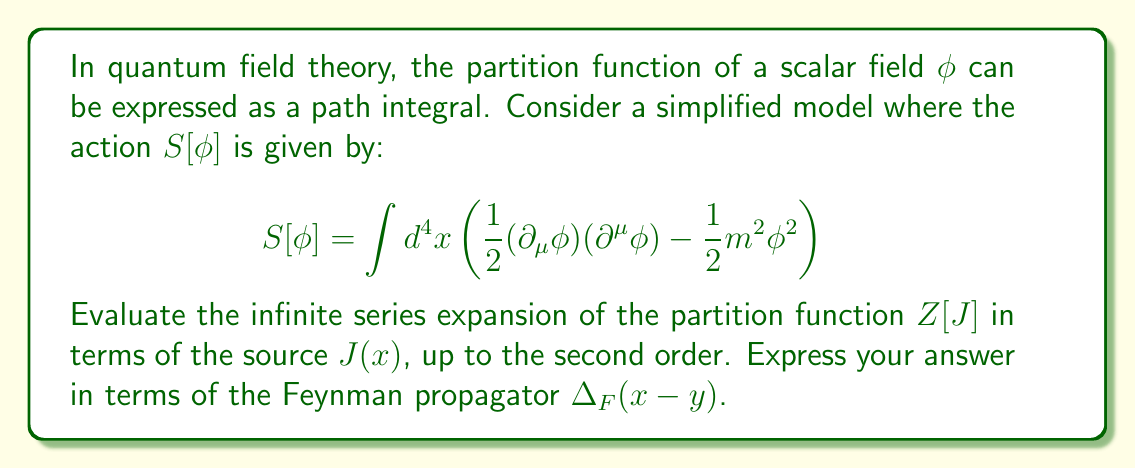Can you answer this question? Let's approach this step-by-step:

1) The partition function $Z[J]$ is given by:

   $$Z[J] = \int \mathcal{D}\phi \exp\left(i\int d^4x \left(\mathcal{L} + J\phi\right)\right)$$

   where $\mathcal{L}$ is the Lagrangian density.

2) For our simplified model, this becomes:

   $$Z[J] = \int \mathcal{D}\phi \exp\left(i\int d^4x \left(-\frac{1}{2}(\partial_\mu\phi)(\partial^\mu\phi) + \frac{1}{2}m^2\phi^2 + J\phi\right)\right)$$

3) We can rewrite this as:

   $$Z[J] = \exp\left(\frac{i}{2}\int d^4x d^4y J(x)\Delta_F(x-y)J(y)\right) Z[0]$$

   where $\Delta_F(x-y)$ is the Feynman propagator.

4) Expanding this exponential up to second order:

   $$Z[J] \approx Z[0]\left(1 + \frac{i}{2}\int d^4x d^4y J(x)\Delta_F(x-y)J(y) + \frac{1}{2!}\left(\frac{i}{2}\int d^4x d^4y J(x)\Delta_F(x-y)J(y)\right)^2\right)$$

5) Simplifying and rearranging:

   $$Z[J] \approx Z[0]\left(1 + \frac{i}{2}\int d^4x d^4y J(x)\Delta_F(x-y)J(y) - \frac{1}{8}\left(\int d^4x d^4y J(x)\Delta_F(x-y)J(y)\right)^2\right)$$

This is the expansion of $Z[J]$ up to second order in $J$.
Answer: $$Z[J] \approx Z[0]\left(1 + \frac{i}{2}\int d^4x d^4y J(x)\Delta_F(x-y)J(y) - \frac{1}{8}\left(\int d^4x d^4y J(x)\Delta_F(x-y)J(y)\right)^2\right)$$ 